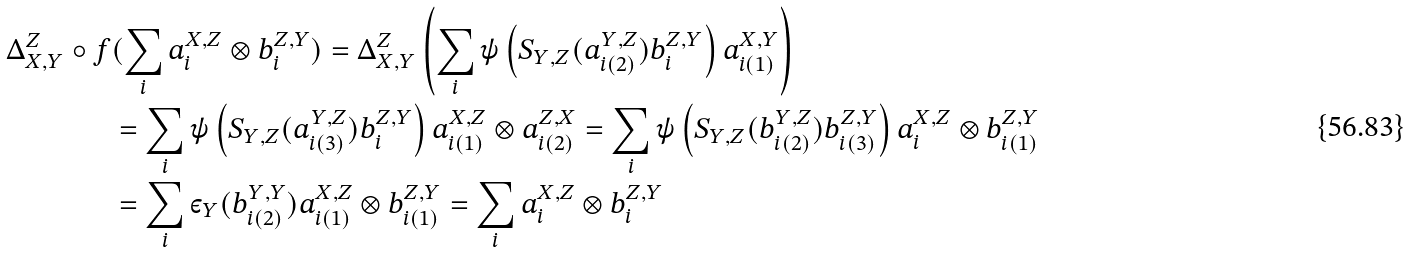Convert formula to latex. <formula><loc_0><loc_0><loc_500><loc_500>\Delta _ { X , Y } ^ { Z } \circ f & ( \sum _ { i } a _ { i } ^ { X , Z } \otimes b _ { i } ^ { Z , Y } ) = \Delta _ { X , Y } ^ { Z } \left ( \sum _ { i } \psi \left ( S _ { Y , Z } ( a ^ { Y , Z } _ { i ( 2 ) } ) b _ { i } ^ { Z , Y } \right ) a ^ { X , Y } _ { i ( 1 ) } \right ) \\ & = \sum _ { i } \psi \left ( S _ { Y , Z } ( a ^ { Y , Z } _ { i ( 3 ) } ) b _ { i } ^ { Z , Y } \right ) a ^ { X , Z } _ { i ( 1 ) } \otimes a _ { i ( 2 ) } ^ { Z , X } = \sum _ { i } \psi \left ( S _ { Y , Z } ( b ^ { Y , Z } _ { i ( 2 ) } ) b _ { i ( 3 ) } ^ { Z , Y } \right ) a ^ { X , Z } _ { i } \otimes b _ { i ( 1 ) } ^ { Z , Y } \\ & = \sum _ { i } \varepsilon _ { Y } ( b _ { i ( 2 ) } ^ { Y , Y } ) a _ { i ( 1 ) } ^ { X , Z } \otimes b _ { i ( 1 ) } ^ { Z , Y } = \sum _ { i } a _ { i } ^ { X , Z } \otimes b _ { i } ^ { Z , Y }</formula> 